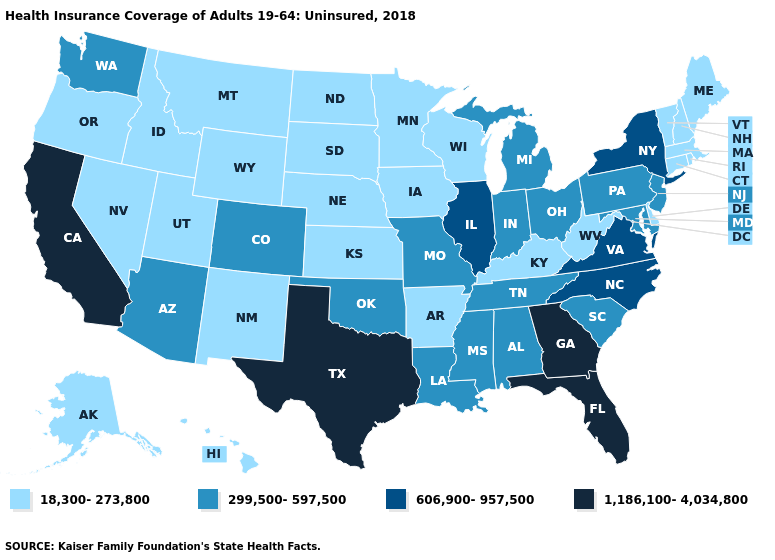Among the states that border Michigan , does Wisconsin have the highest value?
Concise answer only. No. How many symbols are there in the legend?
Answer briefly. 4. Name the states that have a value in the range 1,186,100-4,034,800?
Concise answer only. California, Florida, Georgia, Texas. Name the states that have a value in the range 606,900-957,500?
Be succinct. Illinois, New York, North Carolina, Virginia. Among the states that border Arizona , which have the highest value?
Write a very short answer. California. What is the value of Texas?
Give a very brief answer. 1,186,100-4,034,800. Does the first symbol in the legend represent the smallest category?
Give a very brief answer. Yes. Name the states that have a value in the range 1,186,100-4,034,800?
Short answer required. California, Florida, Georgia, Texas. Does the map have missing data?
Keep it brief. No. Name the states that have a value in the range 1,186,100-4,034,800?
Be succinct. California, Florida, Georgia, Texas. Which states hav the highest value in the Northeast?
Answer briefly. New York. What is the value of South Carolina?
Quick response, please. 299,500-597,500. Which states have the highest value in the USA?
Be succinct. California, Florida, Georgia, Texas. What is the value of Nevada?
Be succinct. 18,300-273,800. 